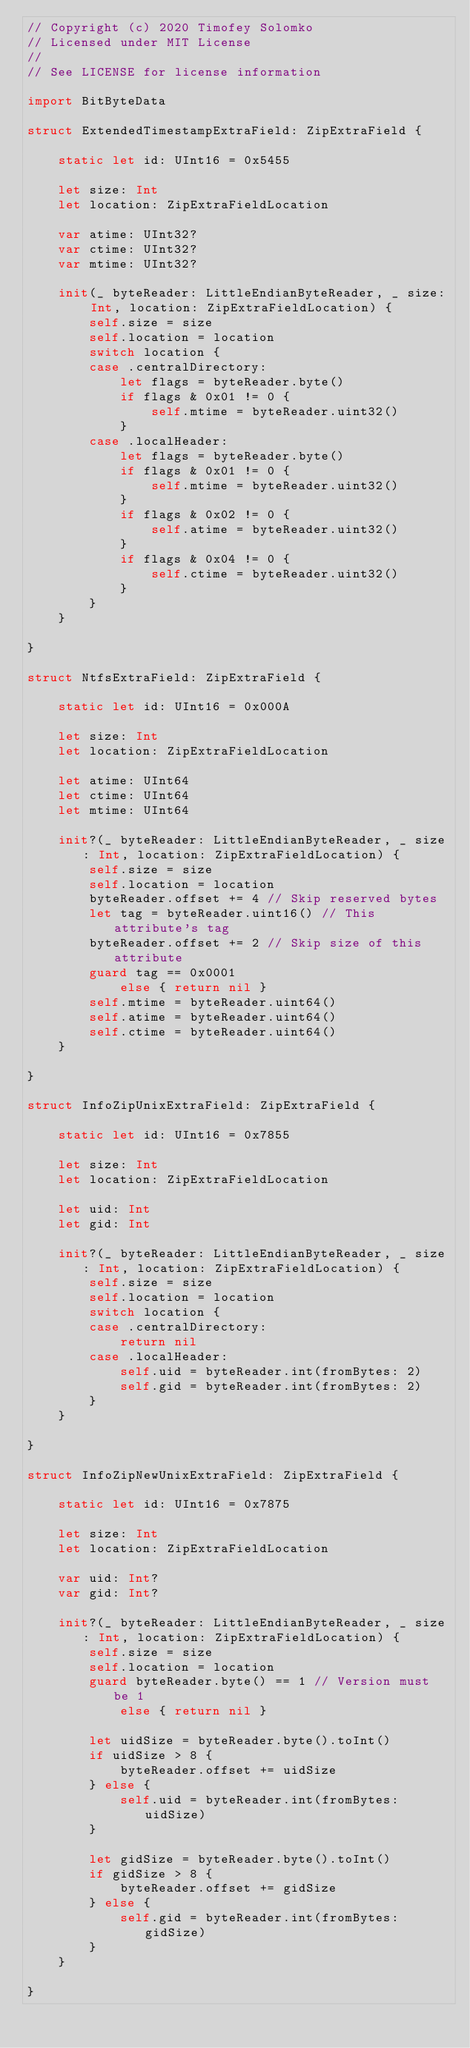Convert code to text. <code><loc_0><loc_0><loc_500><loc_500><_Swift_>// Copyright (c) 2020 Timofey Solomko
// Licensed under MIT License
//
// See LICENSE for license information

import BitByteData

struct ExtendedTimestampExtraField: ZipExtraField {

    static let id: UInt16 = 0x5455

    let size: Int
    let location: ZipExtraFieldLocation

    var atime: UInt32?
    var ctime: UInt32?
    var mtime: UInt32?

    init(_ byteReader: LittleEndianByteReader, _ size: Int, location: ZipExtraFieldLocation) {
        self.size = size
        self.location = location
        switch location {
        case .centralDirectory:
            let flags = byteReader.byte()
            if flags & 0x01 != 0 {
                self.mtime = byteReader.uint32()
            }
        case .localHeader:
            let flags = byteReader.byte()
            if flags & 0x01 != 0 {
                self.mtime = byteReader.uint32()
            }
            if flags & 0x02 != 0 {
                self.atime = byteReader.uint32()
            }
            if flags & 0x04 != 0 {
                self.ctime = byteReader.uint32()
            }
        }
    }

}

struct NtfsExtraField: ZipExtraField {

    static let id: UInt16 = 0x000A

    let size: Int
    let location: ZipExtraFieldLocation

    let atime: UInt64
    let ctime: UInt64
    let mtime: UInt64

    init?(_ byteReader: LittleEndianByteReader, _ size: Int, location: ZipExtraFieldLocation) {
        self.size = size
        self.location = location
        byteReader.offset += 4 // Skip reserved bytes
        let tag = byteReader.uint16() // This attribute's tag
        byteReader.offset += 2 // Skip size of this attribute
        guard tag == 0x0001
            else { return nil }
        self.mtime = byteReader.uint64()
        self.atime = byteReader.uint64()
        self.ctime = byteReader.uint64()
    }

}

struct InfoZipUnixExtraField: ZipExtraField {

    static let id: UInt16 = 0x7855

    let size: Int
    let location: ZipExtraFieldLocation

    let uid: Int
    let gid: Int

    init?(_ byteReader: LittleEndianByteReader, _ size: Int, location: ZipExtraFieldLocation) {
        self.size = size
        self.location = location
        switch location {
        case .centralDirectory:
            return nil
        case .localHeader:
            self.uid = byteReader.int(fromBytes: 2)
            self.gid = byteReader.int(fromBytes: 2)
        }
    }

}

struct InfoZipNewUnixExtraField: ZipExtraField {

    static let id: UInt16 = 0x7875

    let size: Int
    let location: ZipExtraFieldLocation

    var uid: Int?
    var gid: Int?

    init?(_ byteReader: LittleEndianByteReader, _ size: Int, location: ZipExtraFieldLocation) {
        self.size = size
        self.location = location
        guard byteReader.byte() == 1 // Version must be 1
            else { return nil }

        let uidSize = byteReader.byte().toInt()
        if uidSize > 8 {
            byteReader.offset += uidSize
        } else {
            self.uid = byteReader.int(fromBytes: uidSize)
        }

        let gidSize = byteReader.byte().toInt()
        if gidSize > 8 {
            byteReader.offset += gidSize
        } else {
            self.gid = byteReader.int(fromBytes: gidSize)
        }
    }

}
</code> 